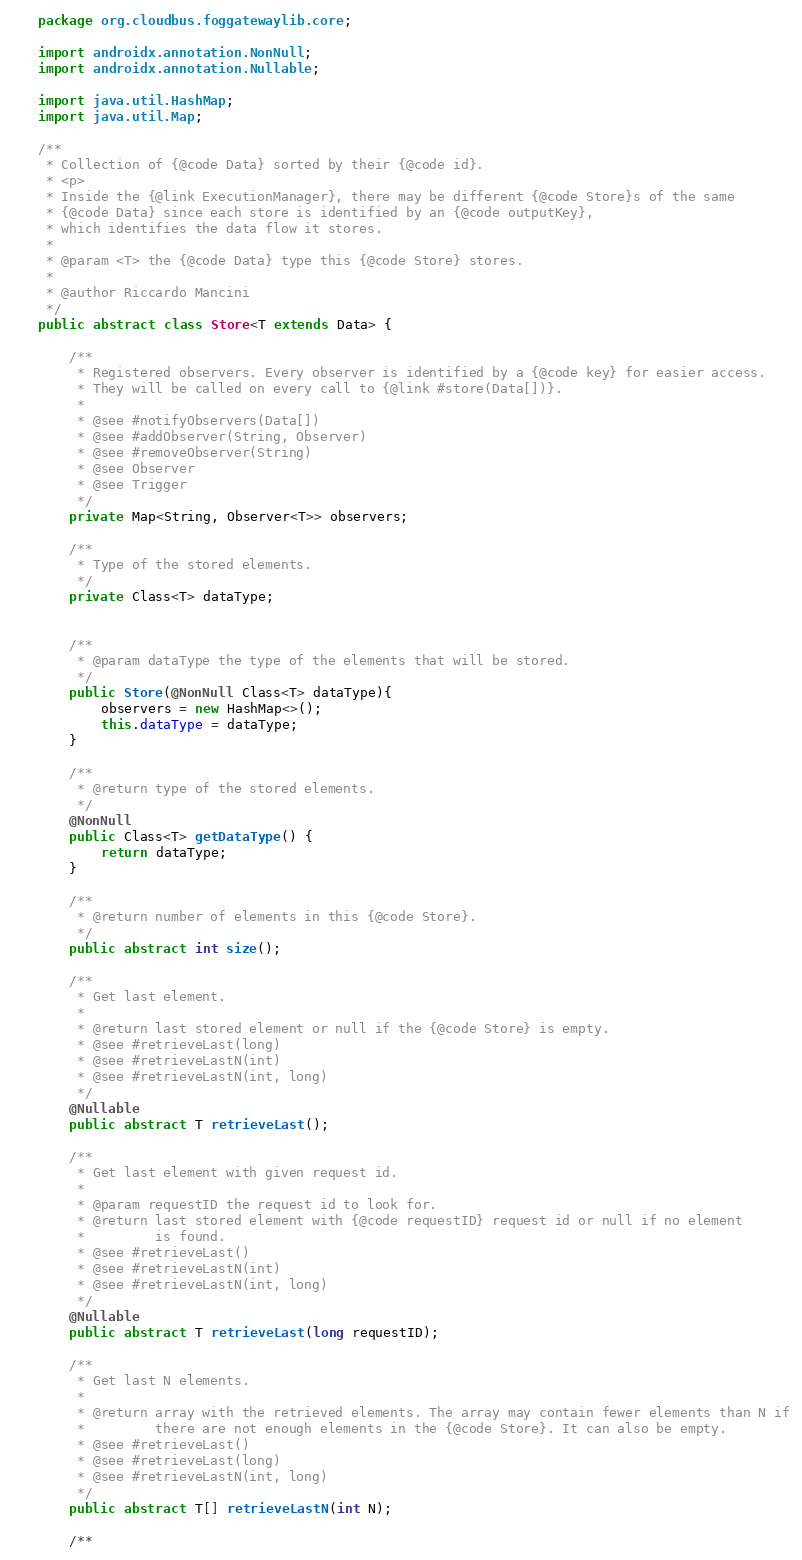<code> <loc_0><loc_0><loc_500><loc_500><_Java_>package org.cloudbus.foggatewaylib.core;

import androidx.annotation.NonNull;
import androidx.annotation.Nullable;

import java.util.HashMap;
import java.util.Map;

/**
 * Collection of {@code Data} sorted by their {@code id}.
 * <p>
 * Inside the {@link ExecutionManager}, there may be different {@code Store}s of the same
 * {@code Data} since each store is identified by an {@code outputKey},
 * which identifies the data flow it stores.
 *
 * @param <T> the {@code Data} type this {@code Store} stores.
 *
 * @author Riccardo Mancini
 */
public abstract class Store<T extends Data> {

    /**
     * Registered observers. Every observer is identified by a {@code key} for easier access.
     * They will be called on every call to {@link #store(Data[])}.
     *
     * @see #notifyObservers(Data[])
     * @see #addObserver(String, Observer)
     * @see #removeObserver(String)
     * @see Observer
     * @see Trigger
     */
    private Map<String, Observer<T>> observers;

    /**
     * Type of the stored elements.
     */
    private Class<T> dataType;


    /**
     * @param dataType the type of the elements that will be stored.
     */
    public Store(@NonNull Class<T> dataType){
        observers = new HashMap<>();
        this.dataType = dataType;
    }

    /**
     * @return type of the stored elements.
     */
    @NonNull
    public Class<T> getDataType() {
        return dataType;
    }

    /**
     * @return number of elements in this {@code Store}.
     */
    public abstract int size();

    /**
     * Get last element.
     *
     * @return last stored element or null if the {@code Store} is empty.
     * @see #retrieveLast(long)
     * @see #retrieveLastN(int)
     * @see #retrieveLastN(int, long)
     */
    @Nullable
    public abstract T retrieveLast();

    /**
     * Get last element with given request id.
     *
     * @param requestID the request id to look for.
     * @return last stored element with {@code requestID} request id or null if no element
     *         is found.
     * @see #retrieveLast()
     * @see #retrieveLastN(int)
     * @see #retrieveLastN(int, long)
     */
    @Nullable
    public abstract T retrieveLast(long requestID);

    /**
     * Get last N elements.
     *
     * @return array with the retrieved elements. The array may contain fewer elements than N if
     *         there are not enough elements in the {@code Store}. It can also be empty.
     * @see #retrieveLast()
     * @see #retrieveLast(long)
     * @see #retrieveLastN(int, long)
     */
    public abstract T[] retrieveLastN(int N);

    /**</code> 